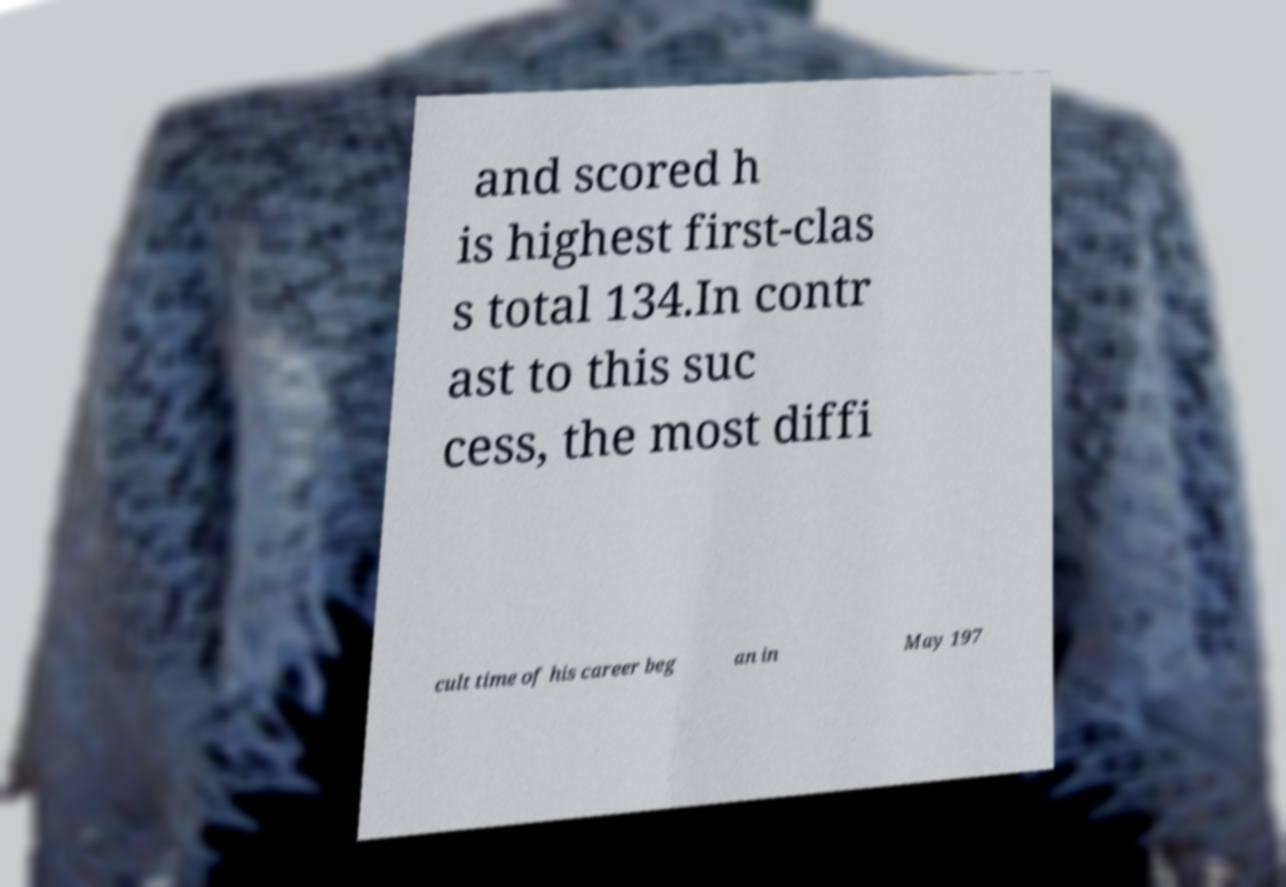Please read and relay the text visible in this image. What does it say? and scored h is highest first-clas s total 134.In contr ast to this suc cess, the most diffi cult time of his career beg an in May 197 